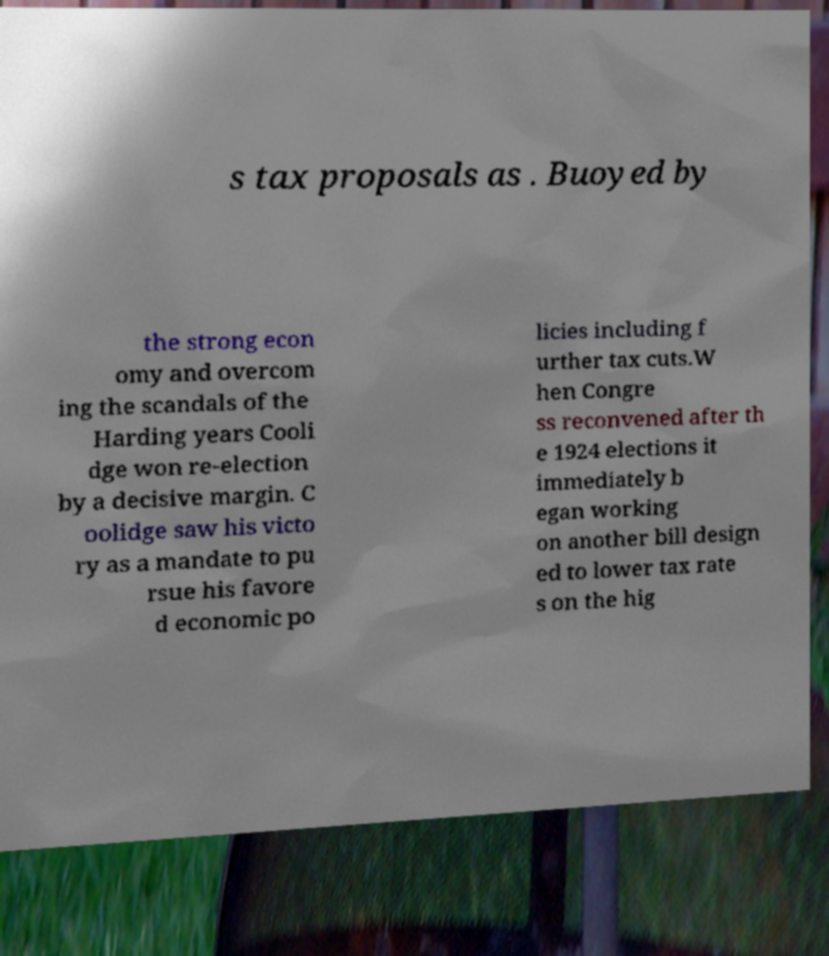Could you assist in decoding the text presented in this image and type it out clearly? s tax proposals as . Buoyed by the strong econ omy and overcom ing the scandals of the Harding years Cooli dge won re-election by a decisive margin. C oolidge saw his victo ry as a mandate to pu rsue his favore d economic po licies including f urther tax cuts.W hen Congre ss reconvened after th e 1924 elections it immediately b egan working on another bill design ed to lower tax rate s on the hig 